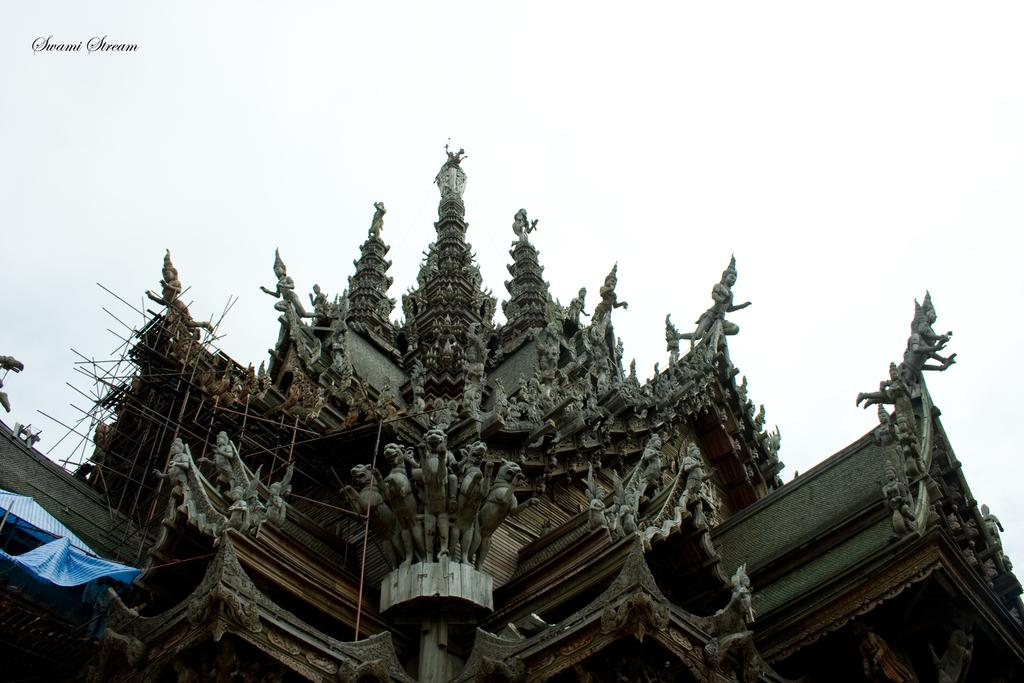What type of structure is depicted in the image? The image contains architecture that resembles a temple. Can you describe the temple in more detail? The temple has many sculptures. What type of plane can be seen flying over the temple in the image? There is no plane visible in the image; it only features the temple with its sculptures. What type of rod is being used to extinguish the flame in the image? There is no flame or rod present in the image; it only features the temple with its sculptures. 